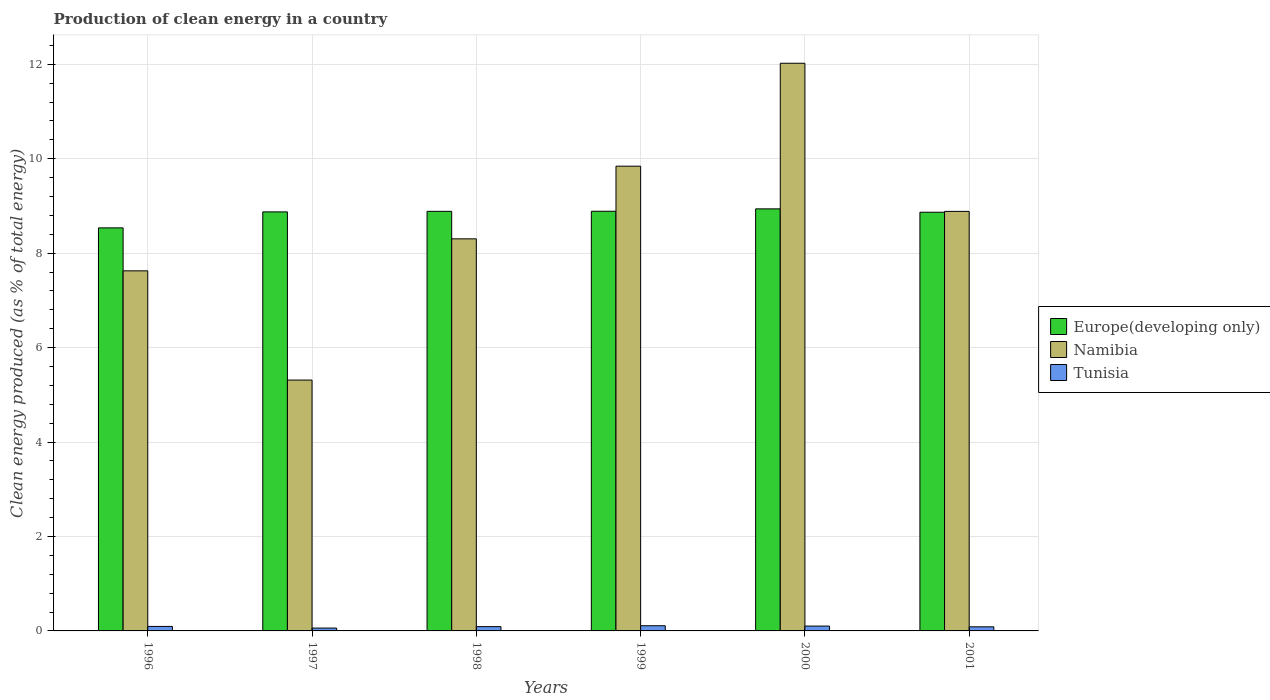How many groups of bars are there?
Make the answer very short. 6. Are the number of bars per tick equal to the number of legend labels?
Offer a very short reply. Yes. How many bars are there on the 4th tick from the right?
Make the answer very short. 3. What is the label of the 6th group of bars from the left?
Provide a short and direct response. 2001. In how many cases, is the number of bars for a given year not equal to the number of legend labels?
Offer a very short reply. 0. What is the percentage of clean energy produced in Tunisia in 1996?
Keep it short and to the point. 0.09. Across all years, what is the maximum percentage of clean energy produced in Tunisia?
Provide a succinct answer. 0.11. Across all years, what is the minimum percentage of clean energy produced in Tunisia?
Ensure brevity in your answer.  0.06. In which year was the percentage of clean energy produced in Namibia minimum?
Provide a short and direct response. 1997. What is the total percentage of clean energy produced in Europe(developing only) in the graph?
Your response must be concise. 52.99. What is the difference between the percentage of clean energy produced in Tunisia in 1997 and that in 1998?
Ensure brevity in your answer.  -0.03. What is the difference between the percentage of clean energy produced in Namibia in 1998 and the percentage of clean energy produced in Tunisia in 2001?
Offer a very short reply. 8.22. What is the average percentage of clean energy produced in Namibia per year?
Your answer should be very brief. 8.67. In the year 1996, what is the difference between the percentage of clean energy produced in Namibia and percentage of clean energy produced in Tunisia?
Provide a short and direct response. 7.53. What is the ratio of the percentage of clean energy produced in Tunisia in 1997 to that in 2000?
Offer a terse response. 0.59. Is the percentage of clean energy produced in Europe(developing only) in 1998 less than that in 2000?
Make the answer very short. Yes. Is the difference between the percentage of clean energy produced in Namibia in 1996 and 2001 greater than the difference between the percentage of clean energy produced in Tunisia in 1996 and 2001?
Give a very brief answer. No. What is the difference between the highest and the second highest percentage of clean energy produced in Tunisia?
Your response must be concise. 0.01. What is the difference between the highest and the lowest percentage of clean energy produced in Europe(developing only)?
Your response must be concise. 0.4. Is the sum of the percentage of clean energy produced in Namibia in 1996 and 2001 greater than the maximum percentage of clean energy produced in Tunisia across all years?
Your response must be concise. Yes. What does the 1st bar from the left in 2000 represents?
Make the answer very short. Europe(developing only). What does the 3rd bar from the right in 1997 represents?
Offer a terse response. Europe(developing only). How many bars are there?
Offer a terse response. 18. How many years are there in the graph?
Give a very brief answer. 6. What is the difference between two consecutive major ticks on the Y-axis?
Your response must be concise. 2. Are the values on the major ticks of Y-axis written in scientific E-notation?
Your answer should be compact. No. How many legend labels are there?
Your response must be concise. 3. What is the title of the graph?
Offer a terse response. Production of clean energy in a country. What is the label or title of the Y-axis?
Ensure brevity in your answer.  Clean energy produced (as % of total energy). What is the Clean energy produced (as % of total energy) in Europe(developing only) in 1996?
Provide a succinct answer. 8.54. What is the Clean energy produced (as % of total energy) of Namibia in 1996?
Keep it short and to the point. 7.63. What is the Clean energy produced (as % of total energy) in Tunisia in 1996?
Offer a terse response. 0.09. What is the Clean energy produced (as % of total energy) in Europe(developing only) in 1997?
Offer a very short reply. 8.87. What is the Clean energy produced (as % of total energy) in Namibia in 1997?
Keep it short and to the point. 5.31. What is the Clean energy produced (as % of total energy) of Tunisia in 1997?
Offer a terse response. 0.06. What is the Clean energy produced (as % of total energy) of Europe(developing only) in 1998?
Give a very brief answer. 8.89. What is the Clean energy produced (as % of total energy) in Namibia in 1998?
Provide a short and direct response. 8.3. What is the Clean energy produced (as % of total energy) in Tunisia in 1998?
Keep it short and to the point. 0.09. What is the Clean energy produced (as % of total energy) of Europe(developing only) in 1999?
Provide a succinct answer. 8.89. What is the Clean energy produced (as % of total energy) of Namibia in 1999?
Offer a terse response. 9.84. What is the Clean energy produced (as % of total energy) in Tunisia in 1999?
Give a very brief answer. 0.11. What is the Clean energy produced (as % of total energy) in Europe(developing only) in 2000?
Keep it short and to the point. 8.94. What is the Clean energy produced (as % of total energy) in Namibia in 2000?
Your response must be concise. 12.02. What is the Clean energy produced (as % of total energy) of Tunisia in 2000?
Give a very brief answer. 0.1. What is the Clean energy produced (as % of total energy) in Europe(developing only) in 2001?
Give a very brief answer. 8.87. What is the Clean energy produced (as % of total energy) of Namibia in 2001?
Ensure brevity in your answer.  8.89. What is the Clean energy produced (as % of total energy) in Tunisia in 2001?
Make the answer very short. 0.09. Across all years, what is the maximum Clean energy produced (as % of total energy) in Europe(developing only)?
Make the answer very short. 8.94. Across all years, what is the maximum Clean energy produced (as % of total energy) of Namibia?
Provide a succinct answer. 12.02. Across all years, what is the maximum Clean energy produced (as % of total energy) in Tunisia?
Your response must be concise. 0.11. Across all years, what is the minimum Clean energy produced (as % of total energy) of Europe(developing only)?
Give a very brief answer. 8.54. Across all years, what is the minimum Clean energy produced (as % of total energy) of Namibia?
Offer a terse response. 5.31. Across all years, what is the minimum Clean energy produced (as % of total energy) in Tunisia?
Make the answer very short. 0.06. What is the total Clean energy produced (as % of total energy) in Europe(developing only) in the graph?
Offer a terse response. 52.99. What is the total Clean energy produced (as % of total energy) of Namibia in the graph?
Offer a very short reply. 51.99. What is the total Clean energy produced (as % of total energy) in Tunisia in the graph?
Your answer should be very brief. 0.55. What is the difference between the Clean energy produced (as % of total energy) of Europe(developing only) in 1996 and that in 1997?
Your response must be concise. -0.34. What is the difference between the Clean energy produced (as % of total energy) in Namibia in 1996 and that in 1997?
Provide a succinct answer. 2.31. What is the difference between the Clean energy produced (as % of total energy) in Tunisia in 1996 and that in 1997?
Your answer should be compact. 0.03. What is the difference between the Clean energy produced (as % of total energy) of Europe(developing only) in 1996 and that in 1998?
Offer a terse response. -0.35. What is the difference between the Clean energy produced (as % of total energy) in Namibia in 1996 and that in 1998?
Your answer should be very brief. -0.68. What is the difference between the Clean energy produced (as % of total energy) of Tunisia in 1996 and that in 1998?
Make the answer very short. 0. What is the difference between the Clean energy produced (as % of total energy) of Europe(developing only) in 1996 and that in 1999?
Ensure brevity in your answer.  -0.35. What is the difference between the Clean energy produced (as % of total energy) in Namibia in 1996 and that in 1999?
Give a very brief answer. -2.22. What is the difference between the Clean energy produced (as % of total energy) of Tunisia in 1996 and that in 1999?
Your answer should be very brief. -0.01. What is the difference between the Clean energy produced (as % of total energy) in Europe(developing only) in 1996 and that in 2000?
Give a very brief answer. -0.4. What is the difference between the Clean energy produced (as % of total energy) in Namibia in 1996 and that in 2000?
Provide a short and direct response. -4.4. What is the difference between the Clean energy produced (as % of total energy) of Tunisia in 1996 and that in 2000?
Provide a succinct answer. -0.01. What is the difference between the Clean energy produced (as % of total energy) in Europe(developing only) in 1996 and that in 2001?
Make the answer very short. -0.33. What is the difference between the Clean energy produced (as % of total energy) in Namibia in 1996 and that in 2001?
Keep it short and to the point. -1.26. What is the difference between the Clean energy produced (as % of total energy) of Tunisia in 1996 and that in 2001?
Make the answer very short. 0.01. What is the difference between the Clean energy produced (as % of total energy) of Europe(developing only) in 1997 and that in 1998?
Offer a very short reply. -0.01. What is the difference between the Clean energy produced (as % of total energy) in Namibia in 1997 and that in 1998?
Your answer should be very brief. -2.99. What is the difference between the Clean energy produced (as % of total energy) in Tunisia in 1997 and that in 1998?
Ensure brevity in your answer.  -0.03. What is the difference between the Clean energy produced (as % of total energy) in Europe(developing only) in 1997 and that in 1999?
Your answer should be compact. -0.01. What is the difference between the Clean energy produced (as % of total energy) in Namibia in 1997 and that in 1999?
Provide a short and direct response. -4.53. What is the difference between the Clean energy produced (as % of total energy) in Tunisia in 1997 and that in 1999?
Offer a terse response. -0.05. What is the difference between the Clean energy produced (as % of total energy) of Europe(developing only) in 1997 and that in 2000?
Provide a short and direct response. -0.06. What is the difference between the Clean energy produced (as % of total energy) of Namibia in 1997 and that in 2000?
Offer a terse response. -6.71. What is the difference between the Clean energy produced (as % of total energy) of Tunisia in 1997 and that in 2000?
Your answer should be very brief. -0.04. What is the difference between the Clean energy produced (as % of total energy) of Europe(developing only) in 1997 and that in 2001?
Ensure brevity in your answer.  0.01. What is the difference between the Clean energy produced (as % of total energy) in Namibia in 1997 and that in 2001?
Provide a succinct answer. -3.57. What is the difference between the Clean energy produced (as % of total energy) of Tunisia in 1997 and that in 2001?
Provide a short and direct response. -0.03. What is the difference between the Clean energy produced (as % of total energy) of Europe(developing only) in 1998 and that in 1999?
Provide a succinct answer. -0. What is the difference between the Clean energy produced (as % of total energy) in Namibia in 1998 and that in 1999?
Offer a very short reply. -1.54. What is the difference between the Clean energy produced (as % of total energy) of Tunisia in 1998 and that in 1999?
Your response must be concise. -0.02. What is the difference between the Clean energy produced (as % of total energy) of Europe(developing only) in 1998 and that in 2000?
Your answer should be very brief. -0.05. What is the difference between the Clean energy produced (as % of total energy) in Namibia in 1998 and that in 2000?
Provide a short and direct response. -3.72. What is the difference between the Clean energy produced (as % of total energy) in Tunisia in 1998 and that in 2000?
Offer a terse response. -0.01. What is the difference between the Clean energy produced (as % of total energy) of Europe(developing only) in 1998 and that in 2001?
Offer a terse response. 0.02. What is the difference between the Clean energy produced (as % of total energy) of Namibia in 1998 and that in 2001?
Make the answer very short. -0.58. What is the difference between the Clean energy produced (as % of total energy) of Tunisia in 1998 and that in 2001?
Ensure brevity in your answer.  0. What is the difference between the Clean energy produced (as % of total energy) in Europe(developing only) in 1999 and that in 2000?
Make the answer very short. -0.05. What is the difference between the Clean energy produced (as % of total energy) in Namibia in 1999 and that in 2000?
Keep it short and to the point. -2.18. What is the difference between the Clean energy produced (as % of total energy) in Tunisia in 1999 and that in 2000?
Your answer should be compact. 0.01. What is the difference between the Clean energy produced (as % of total energy) in Europe(developing only) in 1999 and that in 2001?
Ensure brevity in your answer.  0.02. What is the difference between the Clean energy produced (as % of total energy) in Namibia in 1999 and that in 2001?
Provide a short and direct response. 0.96. What is the difference between the Clean energy produced (as % of total energy) of Tunisia in 1999 and that in 2001?
Your response must be concise. 0.02. What is the difference between the Clean energy produced (as % of total energy) in Europe(developing only) in 2000 and that in 2001?
Your response must be concise. 0.07. What is the difference between the Clean energy produced (as % of total energy) of Namibia in 2000 and that in 2001?
Keep it short and to the point. 3.14. What is the difference between the Clean energy produced (as % of total energy) in Tunisia in 2000 and that in 2001?
Offer a terse response. 0.02. What is the difference between the Clean energy produced (as % of total energy) in Europe(developing only) in 1996 and the Clean energy produced (as % of total energy) in Namibia in 1997?
Your answer should be compact. 3.22. What is the difference between the Clean energy produced (as % of total energy) in Europe(developing only) in 1996 and the Clean energy produced (as % of total energy) in Tunisia in 1997?
Make the answer very short. 8.48. What is the difference between the Clean energy produced (as % of total energy) in Namibia in 1996 and the Clean energy produced (as % of total energy) in Tunisia in 1997?
Your answer should be very brief. 7.57. What is the difference between the Clean energy produced (as % of total energy) of Europe(developing only) in 1996 and the Clean energy produced (as % of total energy) of Namibia in 1998?
Your answer should be compact. 0.23. What is the difference between the Clean energy produced (as % of total energy) of Europe(developing only) in 1996 and the Clean energy produced (as % of total energy) of Tunisia in 1998?
Keep it short and to the point. 8.45. What is the difference between the Clean energy produced (as % of total energy) of Namibia in 1996 and the Clean energy produced (as % of total energy) of Tunisia in 1998?
Provide a succinct answer. 7.54. What is the difference between the Clean energy produced (as % of total energy) in Europe(developing only) in 1996 and the Clean energy produced (as % of total energy) in Namibia in 1999?
Make the answer very short. -1.31. What is the difference between the Clean energy produced (as % of total energy) of Europe(developing only) in 1996 and the Clean energy produced (as % of total energy) of Tunisia in 1999?
Make the answer very short. 8.43. What is the difference between the Clean energy produced (as % of total energy) in Namibia in 1996 and the Clean energy produced (as % of total energy) in Tunisia in 1999?
Provide a succinct answer. 7.52. What is the difference between the Clean energy produced (as % of total energy) of Europe(developing only) in 1996 and the Clean energy produced (as % of total energy) of Namibia in 2000?
Offer a terse response. -3.49. What is the difference between the Clean energy produced (as % of total energy) of Europe(developing only) in 1996 and the Clean energy produced (as % of total energy) of Tunisia in 2000?
Provide a succinct answer. 8.43. What is the difference between the Clean energy produced (as % of total energy) of Namibia in 1996 and the Clean energy produced (as % of total energy) of Tunisia in 2000?
Give a very brief answer. 7.52. What is the difference between the Clean energy produced (as % of total energy) of Europe(developing only) in 1996 and the Clean energy produced (as % of total energy) of Namibia in 2001?
Provide a short and direct response. -0.35. What is the difference between the Clean energy produced (as % of total energy) in Europe(developing only) in 1996 and the Clean energy produced (as % of total energy) in Tunisia in 2001?
Offer a very short reply. 8.45. What is the difference between the Clean energy produced (as % of total energy) in Namibia in 1996 and the Clean energy produced (as % of total energy) in Tunisia in 2001?
Provide a succinct answer. 7.54. What is the difference between the Clean energy produced (as % of total energy) of Europe(developing only) in 1997 and the Clean energy produced (as % of total energy) of Namibia in 1998?
Ensure brevity in your answer.  0.57. What is the difference between the Clean energy produced (as % of total energy) of Europe(developing only) in 1997 and the Clean energy produced (as % of total energy) of Tunisia in 1998?
Provide a succinct answer. 8.78. What is the difference between the Clean energy produced (as % of total energy) of Namibia in 1997 and the Clean energy produced (as % of total energy) of Tunisia in 1998?
Provide a short and direct response. 5.22. What is the difference between the Clean energy produced (as % of total energy) of Europe(developing only) in 1997 and the Clean energy produced (as % of total energy) of Namibia in 1999?
Your response must be concise. -0.97. What is the difference between the Clean energy produced (as % of total energy) in Europe(developing only) in 1997 and the Clean energy produced (as % of total energy) in Tunisia in 1999?
Ensure brevity in your answer.  8.76. What is the difference between the Clean energy produced (as % of total energy) of Namibia in 1997 and the Clean energy produced (as % of total energy) of Tunisia in 1999?
Your answer should be compact. 5.2. What is the difference between the Clean energy produced (as % of total energy) in Europe(developing only) in 1997 and the Clean energy produced (as % of total energy) in Namibia in 2000?
Give a very brief answer. -3.15. What is the difference between the Clean energy produced (as % of total energy) in Europe(developing only) in 1997 and the Clean energy produced (as % of total energy) in Tunisia in 2000?
Provide a short and direct response. 8.77. What is the difference between the Clean energy produced (as % of total energy) of Namibia in 1997 and the Clean energy produced (as % of total energy) of Tunisia in 2000?
Provide a succinct answer. 5.21. What is the difference between the Clean energy produced (as % of total energy) in Europe(developing only) in 1997 and the Clean energy produced (as % of total energy) in Namibia in 2001?
Make the answer very short. -0.01. What is the difference between the Clean energy produced (as % of total energy) of Europe(developing only) in 1997 and the Clean energy produced (as % of total energy) of Tunisia in 2001?
Your response must be concise. 8.79. What is the difference between the Clean energy produced (as % of total energy) in Namibia in 1997 and the Clean energy produced (as % of total energy) in Tunisia in 2001?
Offer a terse response. 5.23. What is the difference between the Clean energy produced (as % of total energy) in Europe(developing only) in 1998 and the Clean energy produced (as % of total energy) in Namibia in 1999?
Give a very brief answer. -0.96. What is the difference between the Clean energy produced (as % of total energy) of Europe(developing only) in 1998 and the Clean energy produced (as % of total energy) of Tunisia in 1999?
Offer a terse response. 8.78. What is the difference between the Clean energy produced (as % of total energy) in Namibia in 1998 and the Clean energy produced (as % of total energy) in Tunisia in 1999?
Ensure brevity in your answer.  8.19. What is the difference between the Clean energy produced (as % of total energy) in Europe(developing only) in 1998 and the Clean energy produced (as % of total energy) in Namibia in 2000?
Your response must be concise. -3.14. What is the difference between the Clean energy produced (as % of total energy) in Europe(developing only) in 1998 and the Clean energy produced (as % of total energy) in Tunisia in 2000?
Offer a very short reply. 8.78. What is the difference between the Clean energy produced (as % of total energy) of Namibia in 1998 and the Clean energy produced (as % of total energy) of Tunisia in 2000?
Provide a succinct answer. 8.2. What is the difference between the Clean energy produced (as % of total energy) in Europe(developing only) in 1998 and the Clean energy produced (as % of total energy) in Namibia in 2001?
Ensure brevity in your answer.  0. What is the difference between the Clean energy produced (as % of total energy) in Europe(developing only) in 1998 and the Clean energy produced (as % of total energy) in Tunisia in 2001?
Offer a terse response. 8.8. What is the difference between the Clean energy produced (as % of total energy) of Namibia in 1998 and the Clean energy produced (as % of total energy) of Tunisia in 2001?
Provide a succinct answer. 8.22. What is the difference between the Clean energy produced (as % of total energy) in Europe(developing only) in 1999 and the Clean energy produced (as % of total energy) in Namibia in 2000?
Ensure brevity in your answer.  -3.13. What is the difference between the Clean energy produced (as % of total energy) of Europe(developing only) in 1999 and the Clean energy produced (as % of total energy) of Tunisia in 2000?
Give a very brief answer. 8.79. What is the difference between the Clean energy produced (as % of total energy) in Namibia in 1999 and the Clean energy produced (as % of total energy) in Tunisia in 2000?
Give a very brief answer. 9.74. What is the difference between the Clean energy produced (as % of total energy) in Europe(developing only) in 1999 and the Clean energy produced (as % of total energy) in Namibia in 2001?
Offer a very short reply. 0. What is the difference between the Clean energy produced (as % of total energy) of Europe(developing only) in 1999 and the Clean energy produced (as % of total energy) of Tunisia in 2001?
Keep it short and to the point. 8.8. What is the difference between the Clean energy produced (as % of total energy) in Namibia in 1999 and the Clean energy produced (as % of total energy) in Tunisia in 2001?
Your answer should be very brief. 9.76. What is the difference between the Clean energy produced (as % of total energy) in Europe(developing only) in 2000 and the Clean energy produced (as % of total energy) in Namibia in 2001?
Give a very brief answer. 0.05. What is the difference between the Clean energy produced (as % of total energy) in Europe(developing only) in 2000 and the Clean energy produced (as % of total energy) in Tunisia in 2001?
Offer a very short reply. 8.85. What is the difference between the Clean energy produced (as % of total energy) in Namibia in 2000 and the Clean energy produced (as % of total energy) in Tunisia in 2001?
Your answer should be compact. 11.94. What is the average Clean energy produced (as % of total energy) in Europe(developing only) per year?
Provide a short and direct response. 8.83. What is the average Clean energy produced (as % of total energy) in Namibia per year?
Your answer should be very brief. 8.67. What is the average Clean energy produced (as % of total energy) in Tunisia per year?
Make the answer very short. 0.09. In the year 1996, what is the difference between the Clean energy produced (as % of total energy) of Europe(developing only) and Clean energy produced (as % of total energy) of Namibia?
Make the answer very short. 0.91. In the year 1996, what is the difference between the Clean energy produced (as % of total energy) in Europe(developing only) and Clean energy produced (as % of total energy) in Tunisia?
Your response must be concise. 8.44. In the year 1996, what is the difference between the Clean energy produced (as % of total energy) of Namibia and Clean energy produced (as % of total energy) of Tunisia?
Your response must be concise. 7.53. In the year 1997, what is the difference between the Clean energy produced (as % of total energy) of Europe(developing only) and Clean energy produced (as % of total energy) of Namibia?
Your response must be concise. 3.56. In the year 1997, what is the difference between the Clean energy produced (as % of total energy) of Europe(developing only) and Clean energy produced (as % of total energy) of Tunisia?
Your answer should be compact. 8.81. In the year 1997, what is the difference between the Clean energy produced (as % of total energy) in Namibia and Clean energy produced (as % of total energy) in Tunisia?
Your answer should be compact. 5.25. In the year 1998, what is the difference between the Clean energy produced (as % of total energy) of Europe(developing only) and Clean energy produced (as % of total energy) of Namibia?
Give a very brief answer. 0.58. In the year 1998, what is the difference between the Clean energy produced (as % of total energy) in Europe(developing only) and Clean energy produced (as % of total energy) in Tunisia?
Make the answer very short. 8.8. In the year 1998, what is the difference between the Clean energy produced (as % of total energy) of Namibia and Clean energy produced (as % of total energy) of Tunisia?
Your response must be concise. 8.21. In the year 1999, what is the difference between the Clean energy produced (as % of total energy) in Europe(developing only) and Clean energy produced (as % of total energy) in Namibia?
Your response must be concise. -0.95. In the year 1999, what is the difference between the Clean energy produced (as % of total energy) in Europe(developing only) and Clean energy produced (as % of total energy) in Tunisia?
Offer a terse response. 8.78. In the year 1999, what is the difference between the Clean energy produced (as % of total energy) in Namibia and Clean energy produced (as % of total energy) in Tunisia?
Keep it short and to the point. 9.73. In the year 2000, what is the difference between the Clean energy produced (as % of total energy) of Europe(developing only) and Clean energy produced (as % of total energy) of Namibia?
Your answer should be compact. -3.08. In the year 2000, what is the difference between the Clean energy produced (as % of total energy) in Europe(developing only) and Clean energy produced (as % of total energy) in Tunisia?
Ensure brevity in your answer.  8.84. In the year 2000, what is the difference between the Clean energy produced (as % of total energy) in Namibia and Clean energy produced (as % of total energy) in Tunisia?
Offer a very short reply. 11.92. In the year 2001, what is the difference between the Clean energy produced (as % of total energy) in Europe(developing only) and Clean energy produced (as % of total energy) in Namibia?
Offer a terse response. -0.02. In the year 2001, what is the difference between the Clean energy produced (as % of total energy) in Europe(developing only) and Clean energy produced (as % of total energy) in Tunisia?
Provide a succinct answer. 8.78. In the year 2001, what is the difference between the Clean energy produced (as % of total energy) of Namibia and Clean energy produced (as % of total energy) of Tunisia?
Provide a succinct answer. 8.8. What is the ratio of the Clean energy produced (as % of total energy) in Europe(developing only) in 1996 to that in 1997?
Your answer should be very brief. 0.96. What is the ratio of the Clean energy produced (as % of total energy) of Namibia in 1996 to that in 1997?
Make the answer very short. 1.44. What is the ratio of the Clean energy produced (as % of total energy) of Tunisia in 1996 to that in 1997?
Give a very brief answer. 1.57. What is the ratio of the Clean energy produced (as % of total energy) in Europe(developing only) in 1996 to that in 1998?
Ensure brevity in your answer.  0.96. What is the ratio of the Clean energy produced (as % of total energy) of Namibia in 1996 to that in 1998?
Make the answer very short. 0.92. What is the ratio of the Clean energy produced (as % of total energy) of Tunisia in 1996 to that in 1998?
Your response must be concise. 1.05. What is the ratio of the Clean energy produced (as % of total energy) of Europe(developing only) in 1996 to that in 1999?
Your response must be concise. 0.96. What is the ratio of the Clean energy produced (as % of total energy) of Namibia in 1996 to that in 1999?
Keep it short and to the point. 0.77. What is the ratio of the Clean energy produced (as % of total energy) in Tunisia in 1996 to that in 1999?
Your answer should be compact. 0.86. What is the ratio of the Clean energy produced (as % of total energy) of Europe(developing only) in 1996 to that in 2000?
Offer a terse response. 0.95. What is the ratio of the Clean energy produced (as % of total energy) in Namibia in 1996 to that in 2000?
Offer a very short reply. 0.63. What is the ratio of the Clean energy produced (as % of total energy) of Tunisia in 1996 to that in 2000?
Give a very brief answer. 0.93. What is the ratio of the Clean energy produced (as % of total energy) of Europe(developing only) in 1996 to that in 2001?
Ensure brevity in your answer.  0.96. What is the ratio of the Clean energy produced (as % of total energy) of Namibia in 1996 to that in 2001?
Your answer should be very brief. 0.86. What is the ratio of the Clean energy produced (as % of total energy) in Tunisia in 1996 to that in 2001?
Make the answer very short. 1.09. What is the ratio of the Clean energy produced (as % of total energy) of Europe(developing only) in 1997 to that in 1998?
Give a very brief answer. 1. What is the ratio of the Clean energy produced (as % of total energy) in Namibia in 1997 to that in 1998?
Provide a short and direct response. 0.64. What is the ratio of the Clean energy produced (as % of total energy) of Tunisia in 1997 to that in 1998?
Make the answer very short. 0.67. What is the ratio of the Clean energy produced (as % of total energy) of Namibia in 1997 to that in 1999?
Give a very brief answer. 0.54. What is the ratio of the Clean energy produced (as % of total energy) of Tunisia in 1997 to that in 1999?
Make the answer very short. 0.55. What is the ratio of the Clean energy produced (as % of total energy) of Europe(developing only) in 1997 to that in 2000?
Keep it short and to the point. 0.99. What is the ratio of the Clean energy produced (as % of total energy) of Namibia in 1997 to that in 2000?
Make the answer very short. 0.44. What is the ratio of the Clean energy produced (as % of total energy) of Tunisia in 1997 to that in 2000?
Make the answer very short. 0.59. What is the ratio of the Clean energy produced (as % of total energy) of Namibia in 1997 to that in 2001?
Ensure brevity in your answer.  0.6. What is the ratio of the Clean energy produced (as % of total energy) in Tunisia in 1997 to that in 2001?
Offer a terse response. 0.7. What is the ratio of the Clean energy produced (as % of total energy) in Namibia in 1998 to that in 1999?
Ensure brevity in your answer.  0.84. What is the ratio of the Clean energy produced (as % of total energy) in Tunisia in 1998 to that in 1999?
Offer a terse response. 0.83. What is the ratio of the Clean energy produced (as % of total energy) of Namibia in 1998 to that in 2000?
Provide a short and direct response. 0.69. What is the ratio of the Clean energy produced (as % of total energy) in Tunisia in 1998 to that in 2000?
Offer a very short reply. 0.89. What is the ratio of the Clean energy produced (as % of total energy) in Namibia in 1998 to that in 2001?
Offer a very short reply. 0.93. What is the ratio of the Clean energy produced (as % of total energy) of Tunisia in 1998 to that in 2001?
Provide a succinct answer. 1.04. What is the ratio of the Clean energy produced (as % of total energy) of Namibia in 1999 to that in 2000?
Your answer should be compact. 0.82. What is the ratio of the Clean energy produced (as % of total energy) in Tunisia in 1999 to that in 2000?
Keep it short and to the point. 1.07. What is the ratio of the Clean energy produced (as % of total energy) of Europe(developing only) in 1999 to that in 2001?
Offer a very short reply. 1. What is the ratio of the Clean energy produced (as % of total energy) in Namibia in 1999 to that in 2001?
Give a very brief answer. 1.11. What is the ratio of the Clean energy produced (as % of total energy) in Tunisia in 1999 to that in 2001?
Provide a short and direct response. 1.26. What is the ratio of the Clean energy produced (as % of total energy) in Europe(developing only) in 2000 to that in 2001?
Your answer should be very brief. 1.01. What is the ratio of the Clean energy produced (as % of total energy) in Namibia in 2000 to that in 2001?
Offer a very short reply. 1.35. What is the ratio of the Clean energy produced (as % of total energy) of Tunisia in 2000 to that in 2001?
Give a very brief answer. 1.18. What is the difference between the highest and the second highest Clean energy produced (as % of total energy) in Europe(developing only)?
Provide a short and direct response. 0.05. What is the difference between the highest and the second highest Clean energy produced (as % of total energy) in Namibia?
Offer a very short reply. 2.18. What is the difference between the highest and the second highest Clean energy produced (as % of total energy) in Tunisia?
Your response must be concise. 0.01. What is the difference between the highest and the lowest Clean energy produced (as % of total energy) of Europe(developing only)?
Offer a very short reply. 0.4. What is the difference between the highest and the lowest Clean energy produced (as % of total energy) of Namibia?
Your response must be concise. 6.71. What is the difference between the highest and the lowest Clean energy produced (as % of total energy) of Tunisia?
Your answer should be very brief. 0.05. 